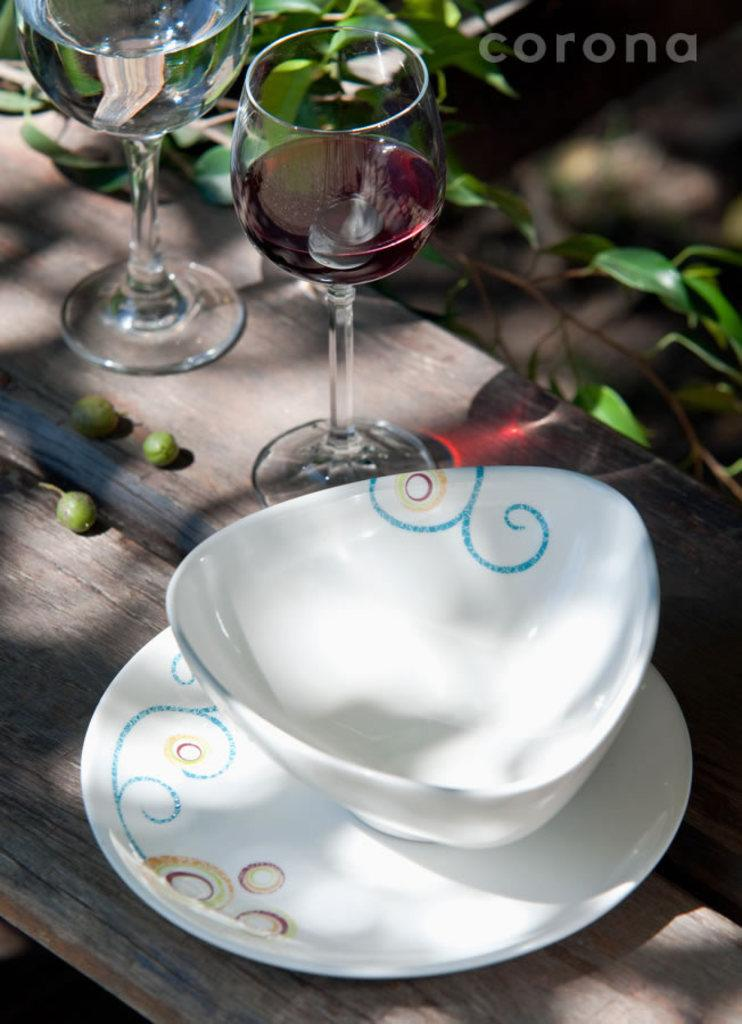How many glasses can be seen in the image? There are two glasses in the image. What other objects are present on the table? There is a plate and a bowl in the image. What type of food is visible in the image? There are fruits in the image. Where are the creepers located in the image? The creepers are visible in the background of the image. What else can be seen in the background of the image? There is text visible in the background of the image. Can you tell if the image was taken during the day or night? The image was likely taken during the day, as there is no indication of darkness or artificial lighting. What type of jewel is being displayed on the chessboard in the image? There is no chessboard or jewel present in the image. What is the reason for the protest taking place in the image? There is no protest or any indication of a protest in the image. 